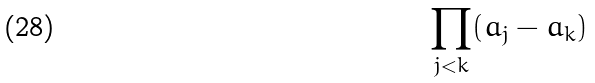<formula> <loc_0><loc_0><loc_500><loc_500>\prod _ { j < k } ( a _ { j } - a _ { k } )</formula> 